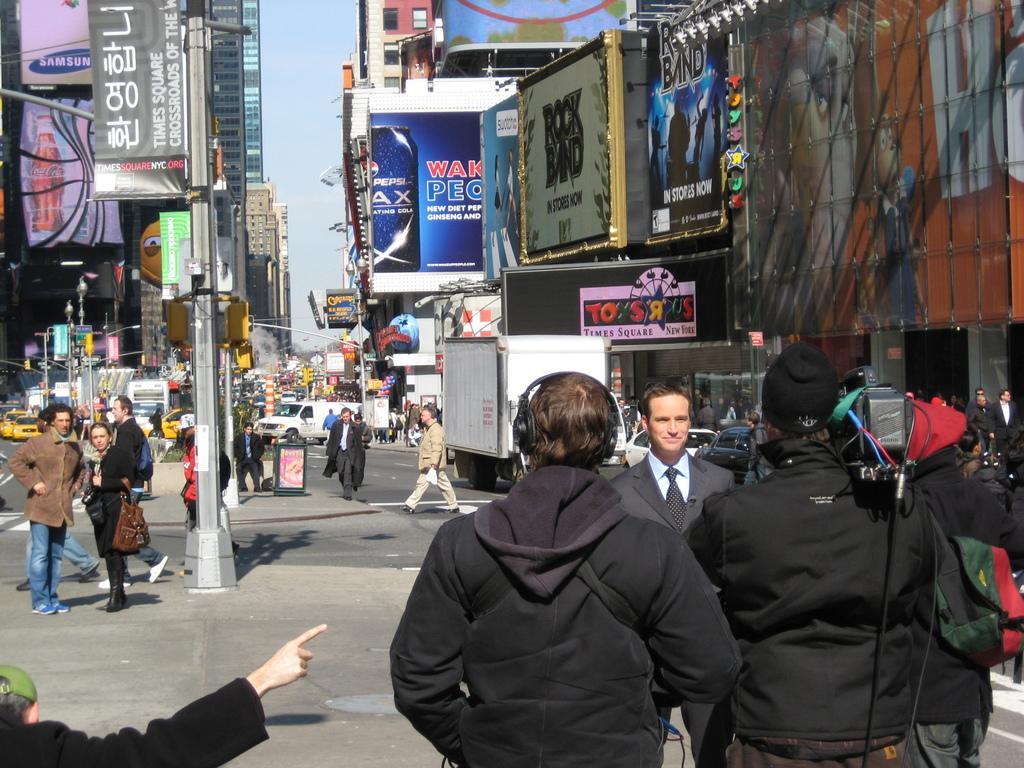How would you summarize this image in a sentence or two? In this picture I can see the path in front on which there are number of people and in the middle of this picture I see the road on which there are number of vehicles and I see the poles and I see number of buildings on which there boards, on which there are pictures of few things and few things written and in the background I see the sky. 